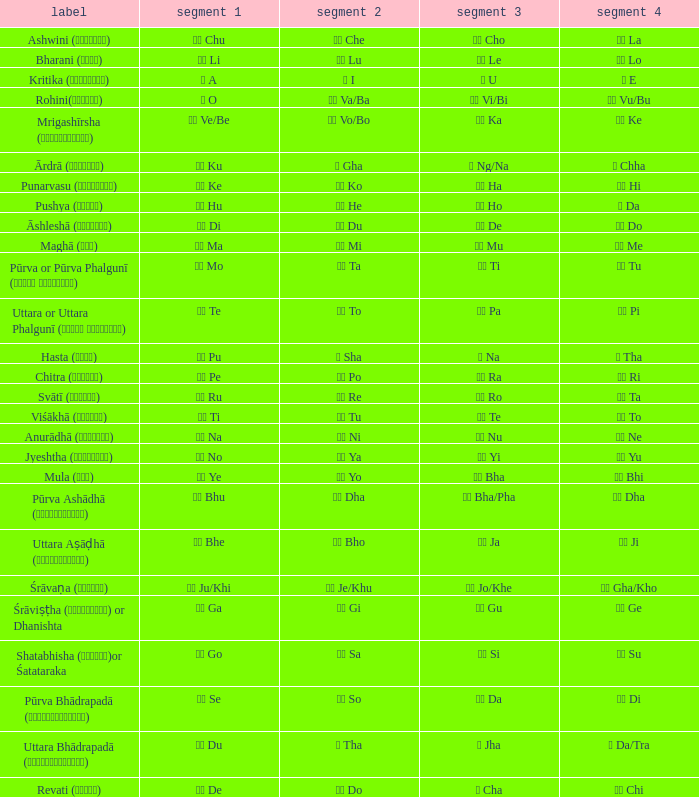Which Pada 3 has a Pada 1 of टे te? पा Pa. 